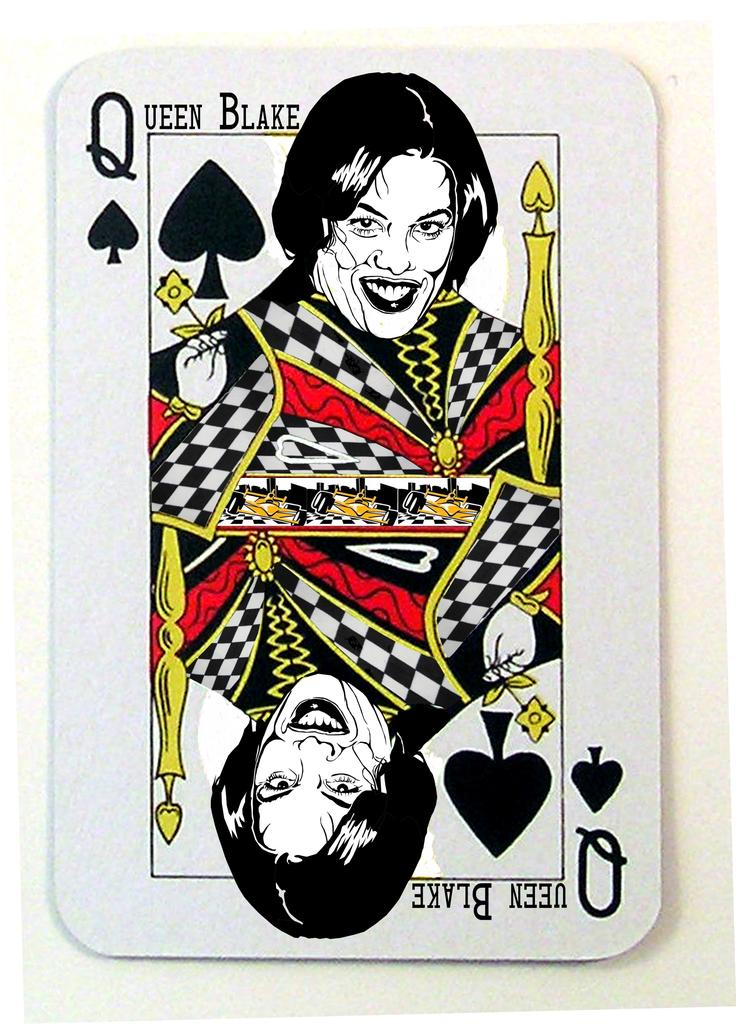What is the main subject in the center of the image? There is a playing card in the center of the image. What is the writer teaching about in the image? There is no writer or teaching activity present in the image; it only features a playing card. When was the birth of the person depicted on the playing card? There is no person depicted on the playing card, as it is a symbol or design used in card games. 